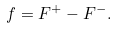<formula> <loc_0><loc_0><loc_500><loc_500>f = F ^ { + } - F ^ { - } .</formula> 